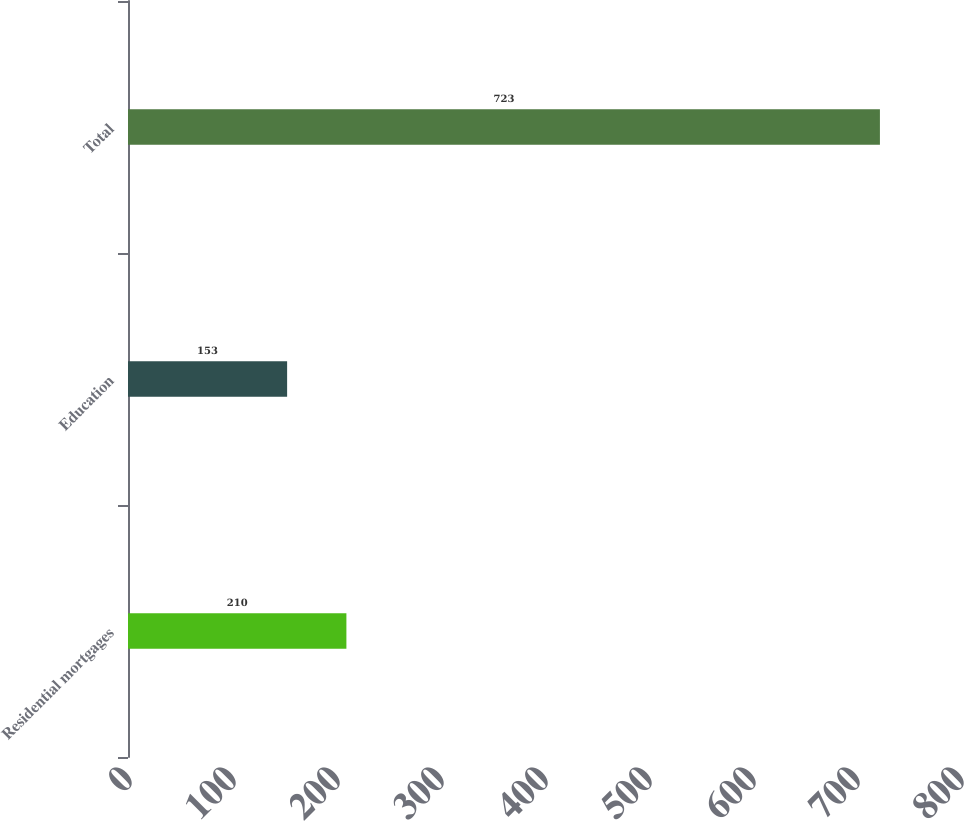Convert chart. <chart><loc_0><loc_0><loc_500><loc_500><bar_chart><fcel>Residential mortgages<fcel>Education<fcel>Total<nl><fcel>210<fcel>153<fcel>723<nl></chart> 